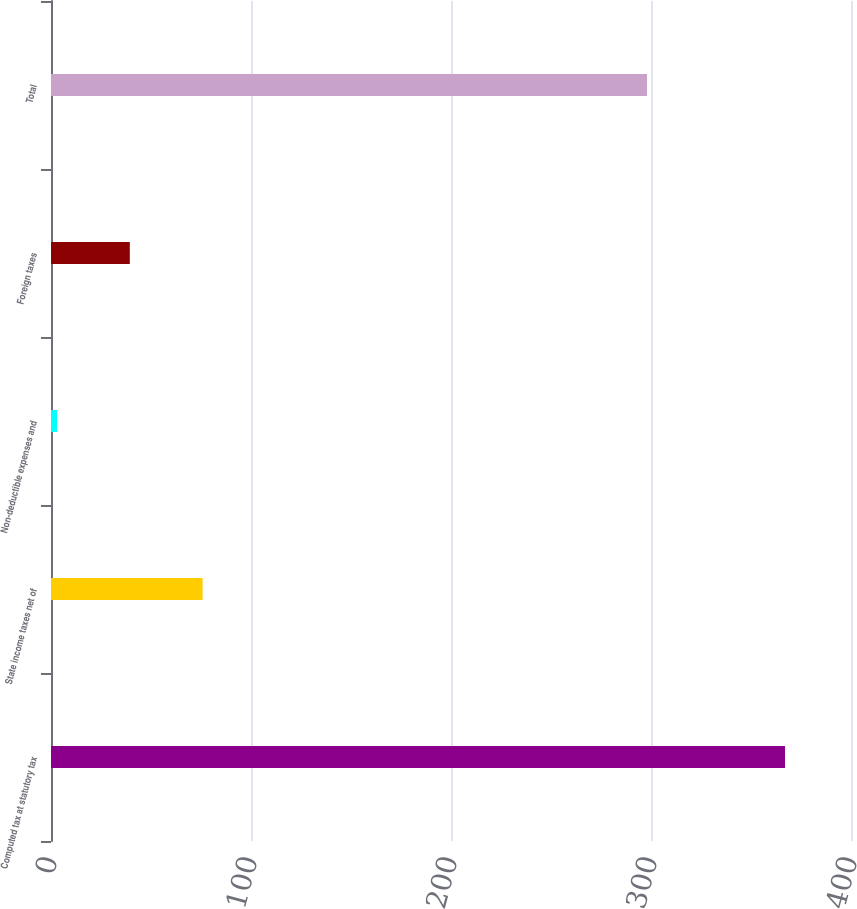<chart> <loc_0><loc_0><loc_500><loc_500><bar_chart><fcel>Computed tax at statutory tax<fcel>State income taxes net of<fcel>Non-deductible expenses and<fcel>Foreign taxes<fcel>Total<nl><fcel>367<fcel>75.8<fcel>3<fcel>39.4<fcel>298<nl></chart> 